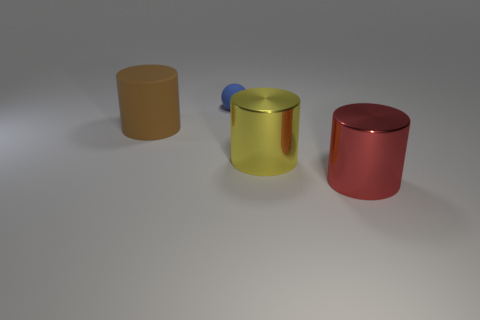Subtract all big brown cylinders. How many cylinders are left? 2 Subtract all red cylinders. How many cylinders are left? 2 Add 1 large gray rubber things. How many objects exist? 5 Subtract all purple cylinders. Subtract all brown spheres. How many cylinders are left? 3 Subtract all large matte cylinders. Subtract all matte cylinders. How many objects are left? 2 Add 4 red cylinders. How many red cylinders are left? 5 Add 2 red matte cubes. How many red matte cubes exist? 2 Subtract 0 yellow cubes. How many objects are left? 4 Subtract all spheres. How many objects are left? 3 